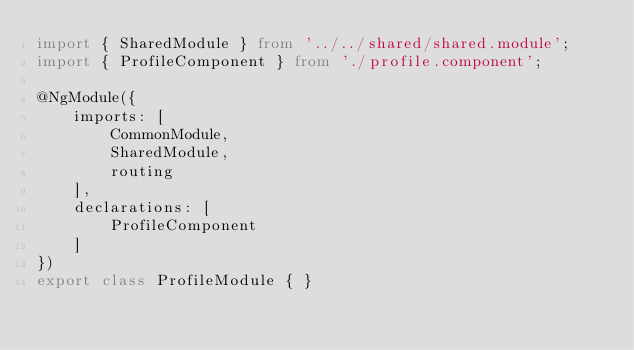Convert code to text. <code><loc_0><loc_0><loc_500><loc_500><_TypeScript_>import { SharedModule } from '../../shared/shared.module';
import { ProfileComponent } from './profile.component';

@NgModule({
    imports: [
        CommonModule,
        SharedModule,
        routing
    ],
    declarations: [
        ProfileComponent
    ]
})
export class ProfileModule { }
</code> 